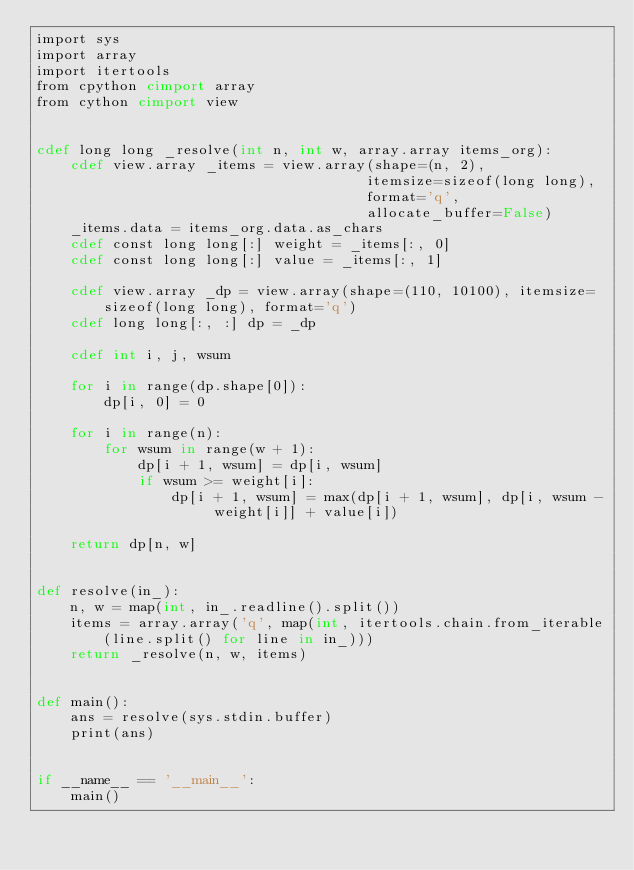<code> <loc_0><loc_0><loc_500><loc_500><_Cython_>import sys
import array
import itertools
from cpython cimport array
from cython cimport view


cdef long long _resolve(int n, int w, array.array items_org):
    cdef view.array _items = view.array(shape=(n, 2),
                                       itemsize=sizeof(long long),
                                       format='q',
                                       allocate_buffer=False)
    _items.data = items_org.data.as_chars
    cdef const long long[:] weight = _items[:, 0]
    cdef const long long[:] value = _items[:, 1]

    cdef view.array _dp = view.array(shape=(110, 10100), itemsize=sizeof(long long), format='q')
    cdef long long[:, :] dp = _dp

    cdef int i, j, wsum

    for i in range(dp.shape[0]):
        dp[i, 0] = 0

    for i in range(n):
        for wsum in range(w + 1):
            dp[i + 1, wsum] = dp[i, wsum]
            if wsum >= weight[i]:
                dp[i + 1, wsum] = max(dp[i + 1, wsum], dp[i, wsum - weight[i]] + value[i])

    return dp[n, w]


def resolve(in_):
    n, w = map(int, in_.readline().split())
    items = array.array('q', map(int, itertools.chain.from_iterable(line.split() for line in in_)))
    return _resolve(n, w, items)


def main():
    ans = resolve(sys.stdin.buffer)
    print(ans)


if __name__ == '__main__':
    main()
</code> 